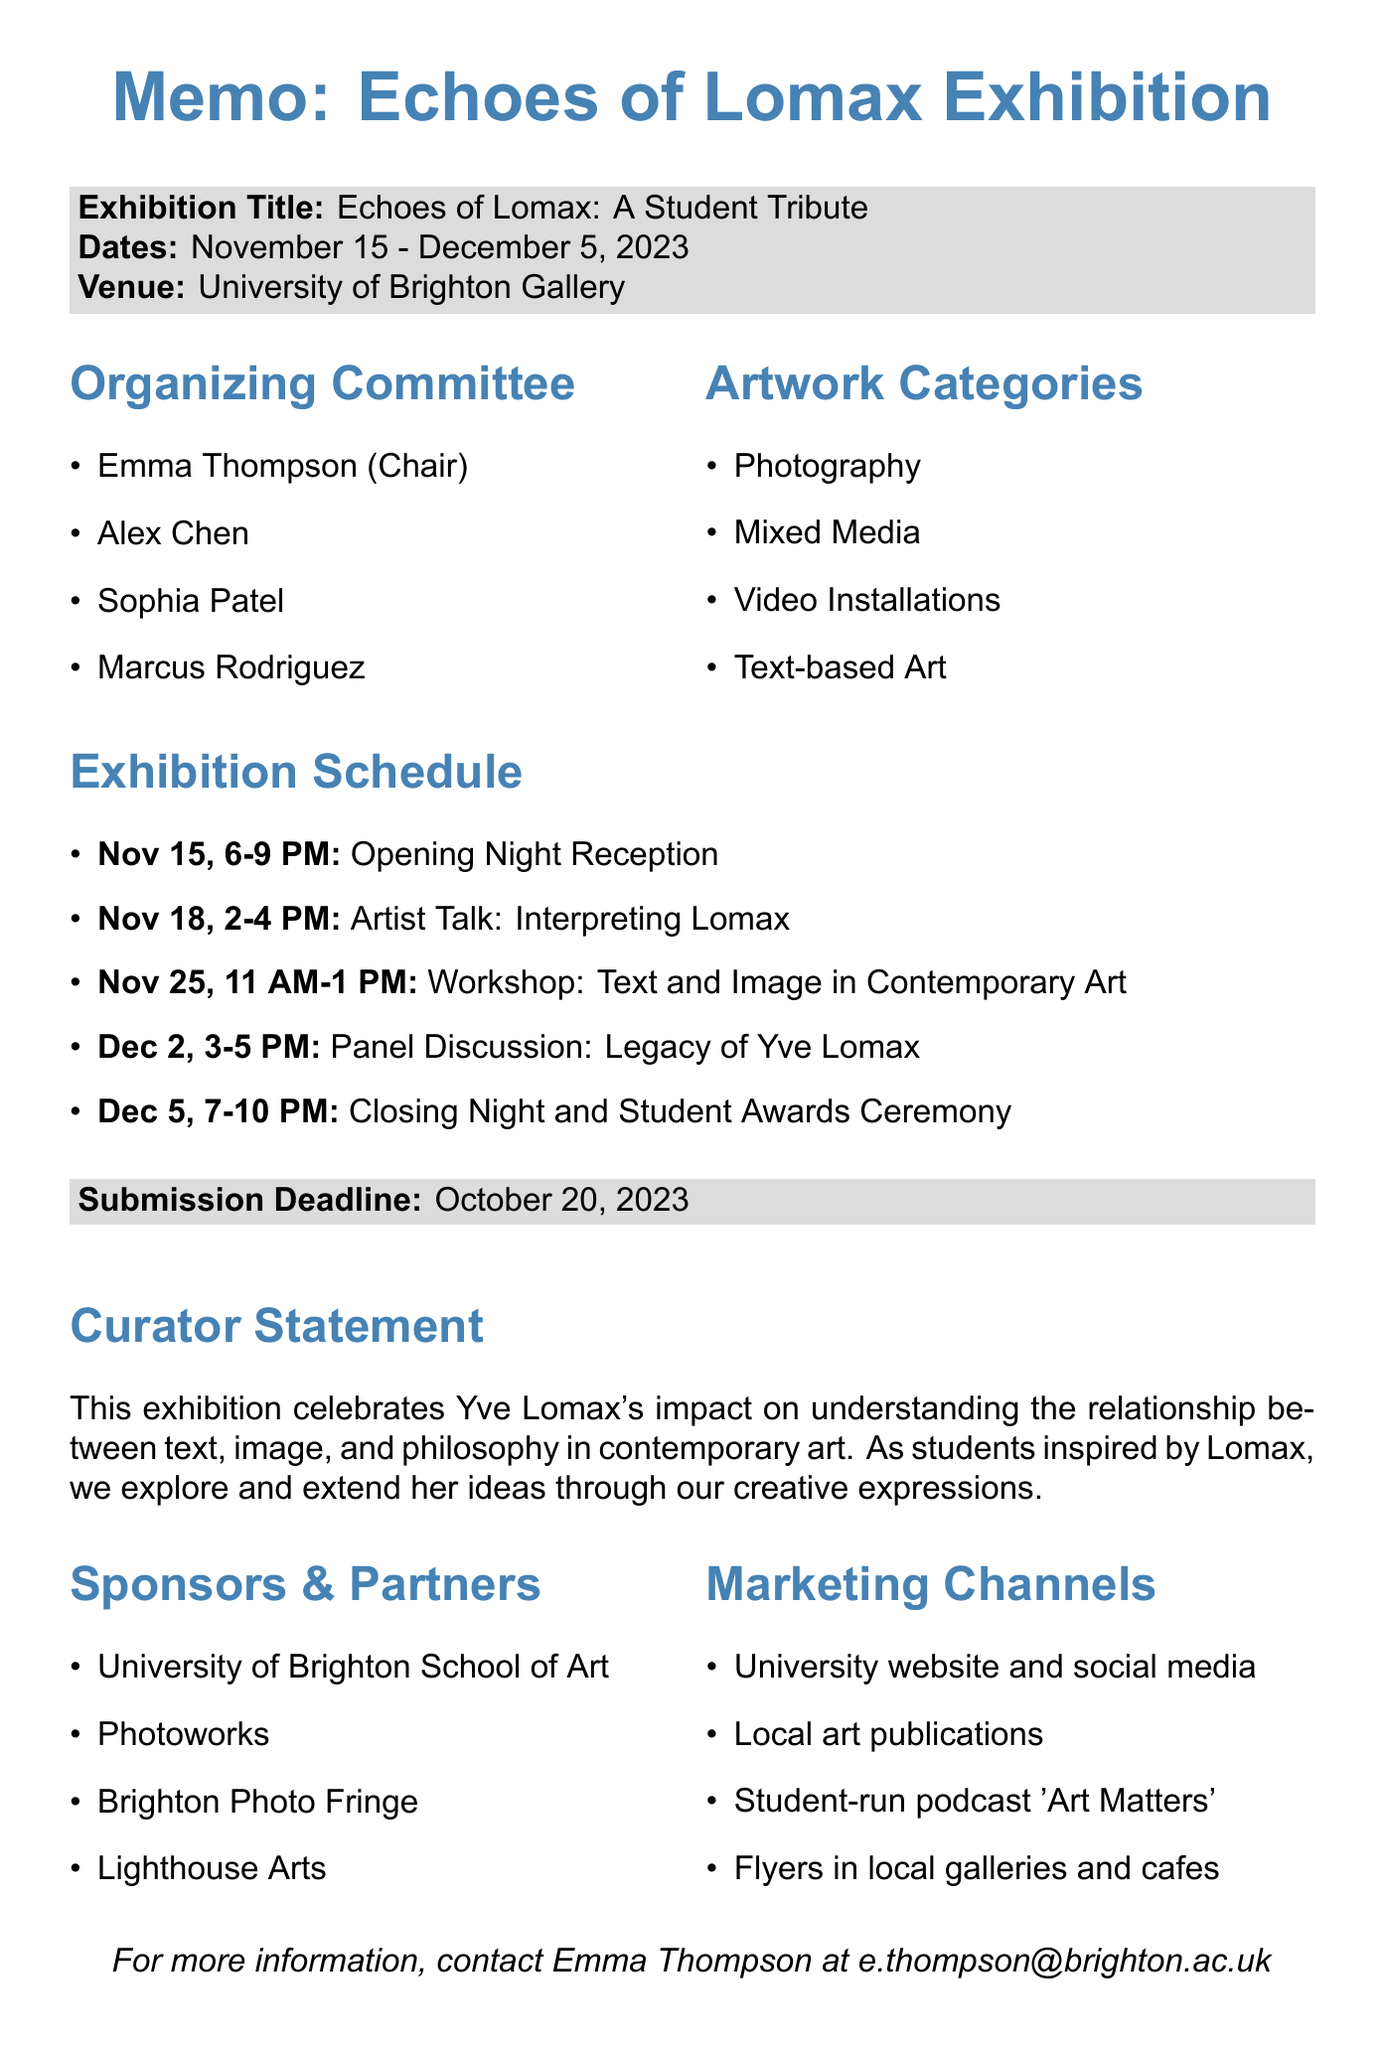what is the title of the exhibition? The title of the exhibition is mentioned at the beginning of the memo.
Answer: Echoes of Lomax: A Student Tribute when does the exhibition start? The start date of the exhibition is provided in the exhibition dates section.
Answer: November 15, 2023 who is the chair of the organizing committee? The name of the chair of the organizing committee is included in the organizing committee list.
Answer: Emma Thompson what event is scheduled for November 25, 2023? The specific event happening on that date is detailed in the exhibition schedule.
Answer: Workshop: Text and Image in Contemporary Art how many artwork categories are listed? The number of artwork categories can be counted from the provided list.
Answer: 4 who will speak at the Opening Night Reception? The guest speaker at the Opening Night Reception is mentioned in the event description.
Answer: Dr. Sarah Johnson what is the submission deadline for artwork? The submission deadline is clearly stated in the document.
Answer: October 20, 2023 what is the budget allocation for venue costs? The specific budget allocation for venue costs is outlined in the budget section.
Answer: £1,500 which organization is listed as a partner? One of the sponsors or partners can be chosen from the partners list.
Answer: University of Brighton School of Art 